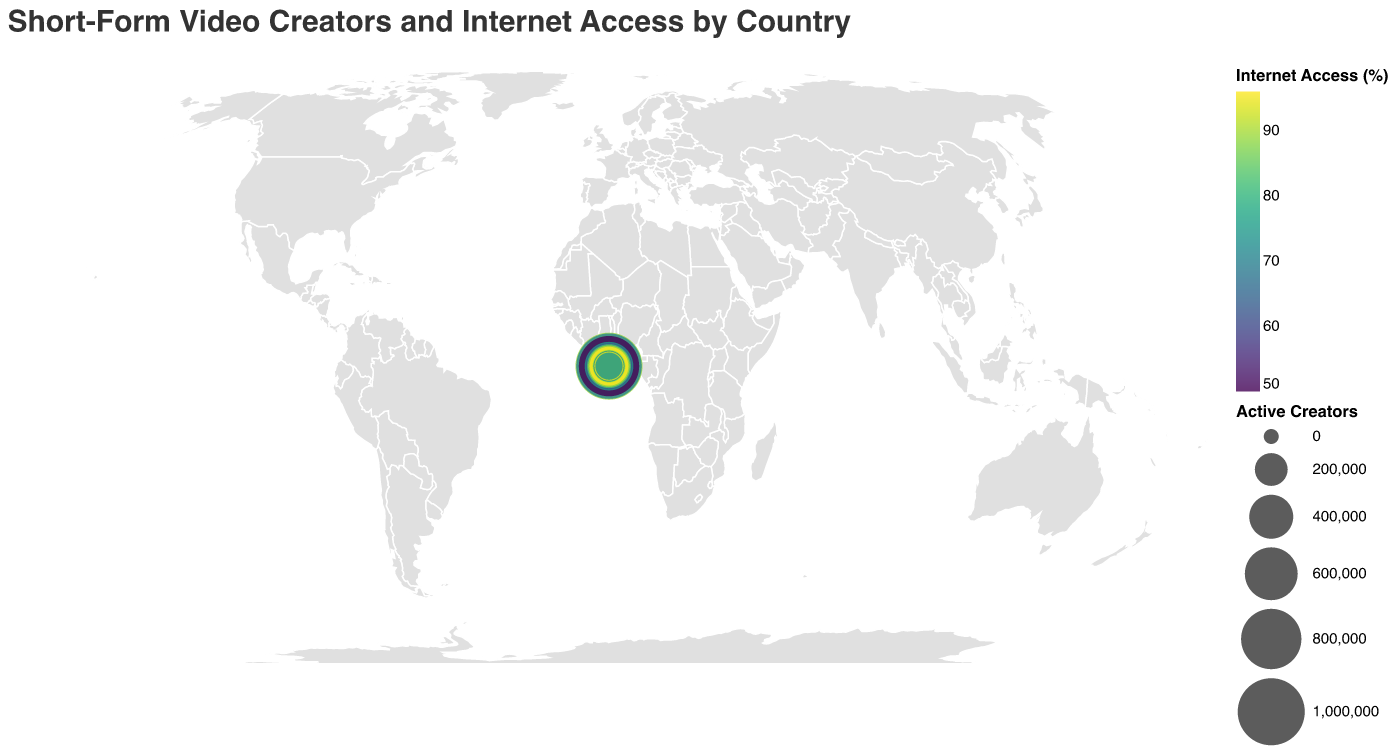What's the title of the figure? The title is located at the top of the figure and summarises the data being presented
Answer: Short-Form Video Creators and Internet Access by Country Which country has the highest number of active short-form video creators? By observing the size of the circles, the country with the largest circle has the highest number of active creators
Answer: USA How does internet access in Brazil compare to that in Mexico? Compare the color shades of the circles for these two countries, with darker shades indicating higher internet access
Answer: Brazil has higher internet access than Mexico What is the relationship between internet access and smartphone penetration in South Korea? Utilize the tooltip information for South Korea and compare the values of Internet Access and Smartphone Penetration
Answer: High internet access (96%) and high smartphone penetration (95%) Which countries have internet access of 90% or more? Check the color legend and tooltip values to identify countries with internet access at or above 90%
Answer: Japan, Germany, Canada, United Kingdom, Spain, South Korea Identify the country with the lowest smartphone penetration among the top 5 countries with the most active creators First identify the top 5 countries by the size of their circles, then check tooltip information for smartphone penetration
Answer: India (32%) What's the average internet access rate of countries with over 300,000 active creators? Identify countries with more than 300,000 active creators and calculate the average of their internet access rates using the tooltip
Answer: (89+70+50+74+64+83)/6 ≈ 71.67% Is there a noticeable correlation between number of active creators and smartphone penetration? Observe the general trend by comparing the size of the circles (active creators) with the depths of their colors (smartphone penetration)
Answer: Generally, countries with higher active creators have higher smartphone penetration What's the primary notable platform in Russia? Identify Russia using the map or tooltip and check the tooltip information for notable platform
Answer: VKontakte Compare the internet accessibility of China and the United States Check the tooltip to compare the "Internet Access" values of China and USA
Answer: USA (89%) has higher internet access than China (70%) 